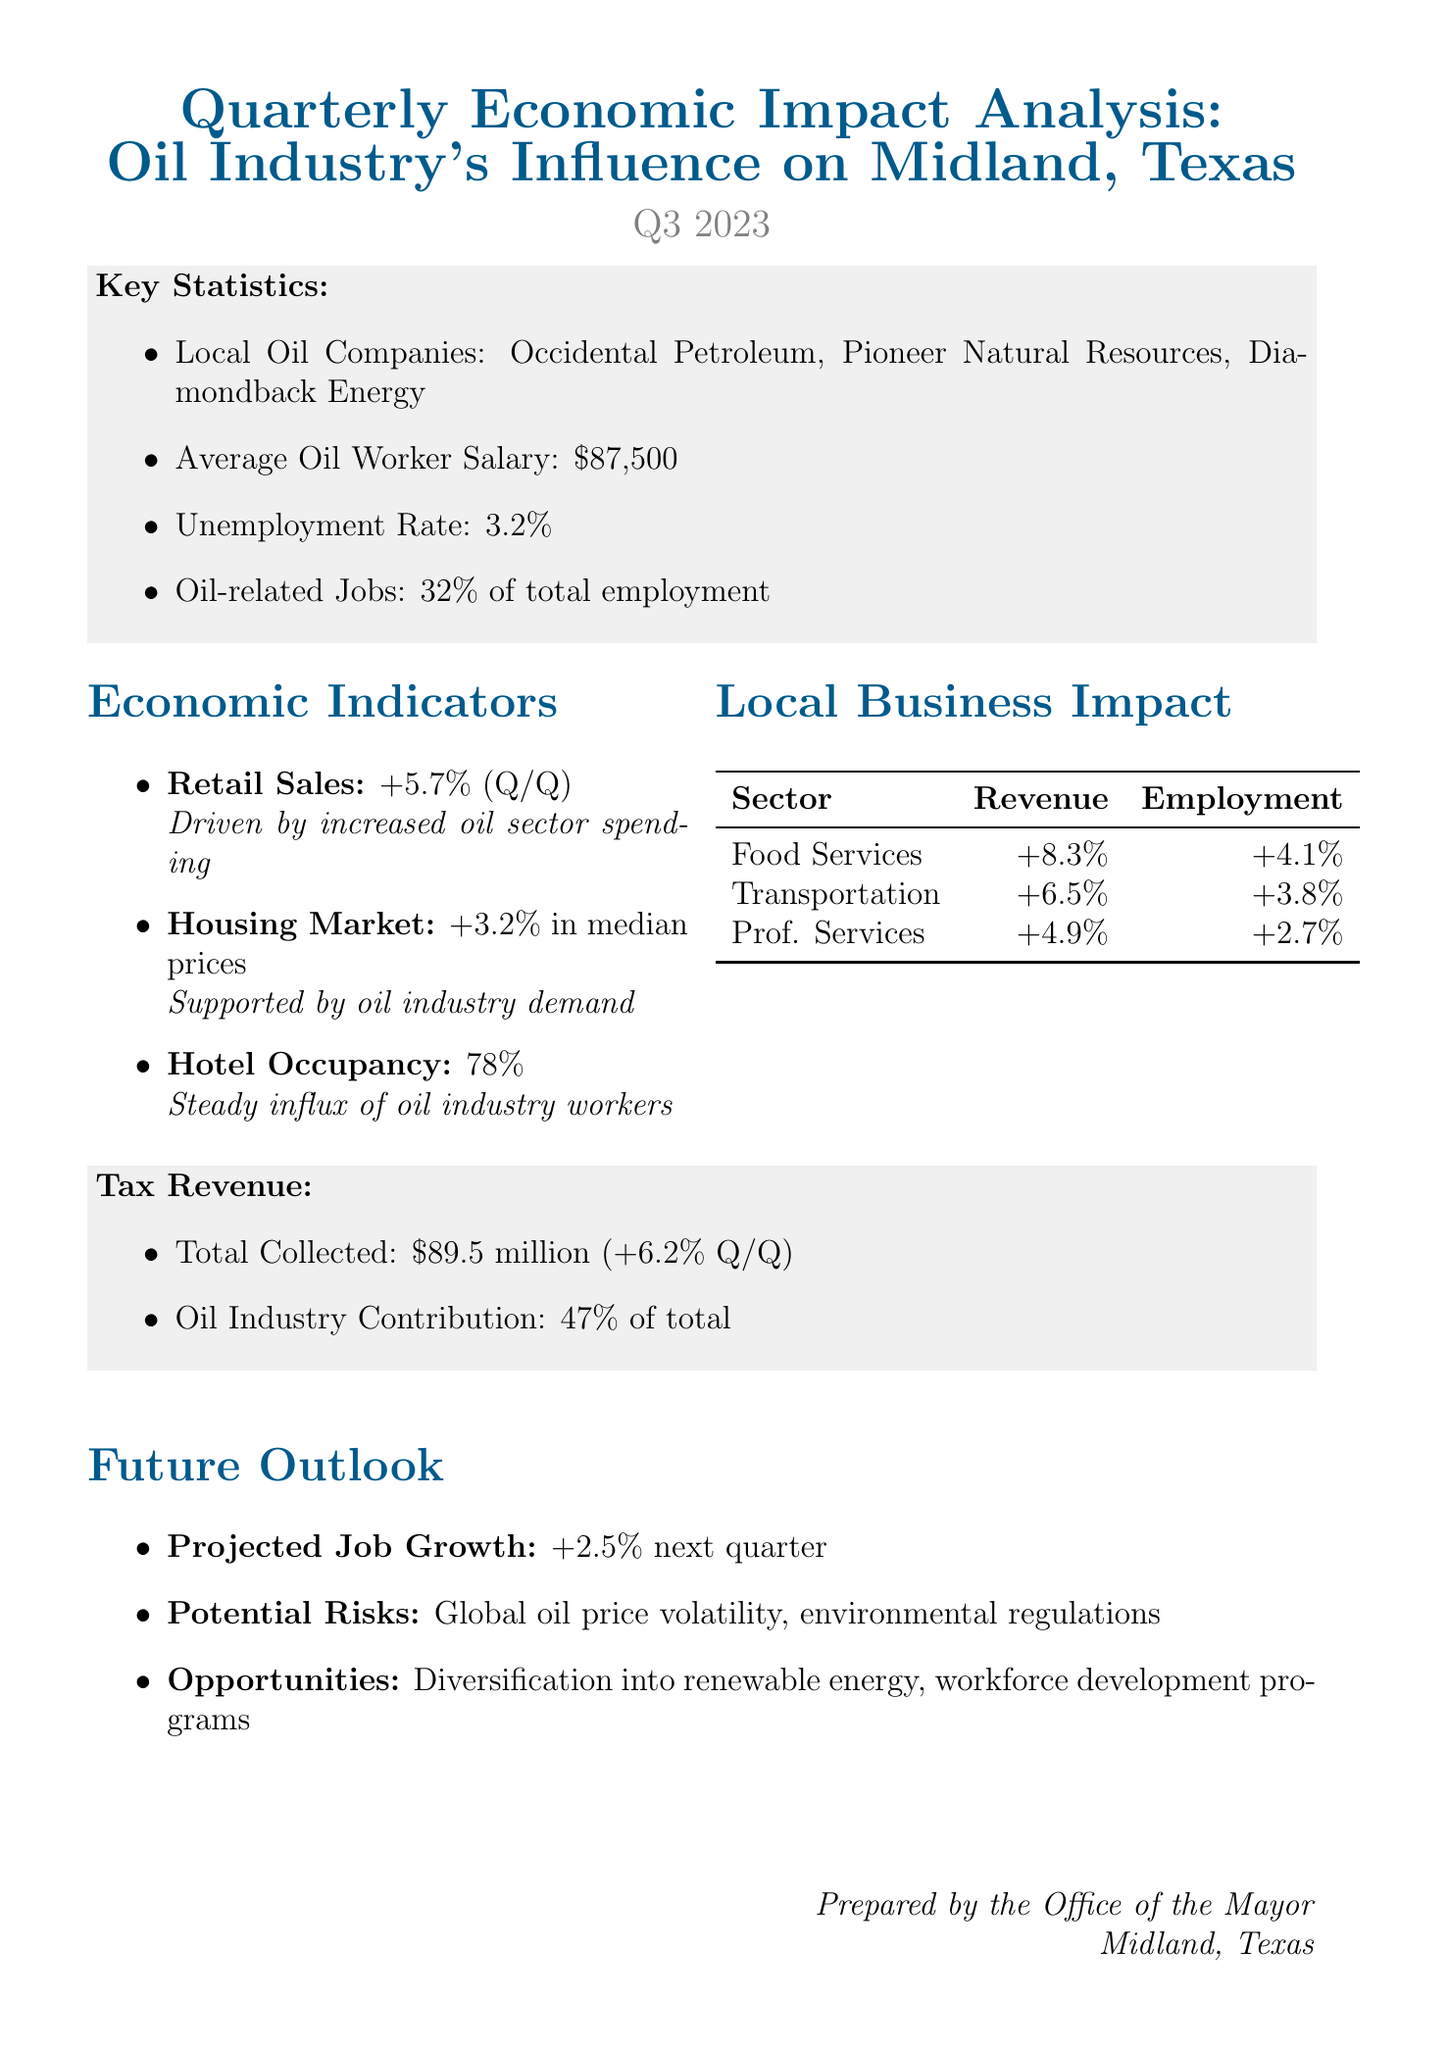What is the average oil worker salary? The document states the average oil worker salary in the key statistics section.
Answer: $87,500 What is the unemployment rate in Midland? The unemployment rate is provided in the key statistics section of the report.
Answer: 3.2% What percentage of total employment do oil-related jobs account for? The document indicates the percentage of oil-related jobs in the key statistics section.
Answer: 32% What was the change in retail sales compared to the previous quarter? The economic indicators section outlines the change in retail sales.
Answer: +5.7% What is the percentage change in median home prices? The change in housing market is provided in the economic indicators section.
Answer: +3.2% What was the total tax revenue collected during this quarter? The total tax revenue collected is mentioned in the tax revenue section of the report.
Answer: $89.5 million How much did the oil industry contribute to the total tax revenue? The oil industry contribution is listed in the tax revenue section.
Answer: 47% What is the projected job growth for the next quarter? The future outlook section forecasts the job growth for the next quarter.
Answer: +2.5% What were the potential risks mentioned in the future outlook? The future outlook section lists potential risks impacting the economy.
Answer: Volatility in global oil prices, environmental regulations 